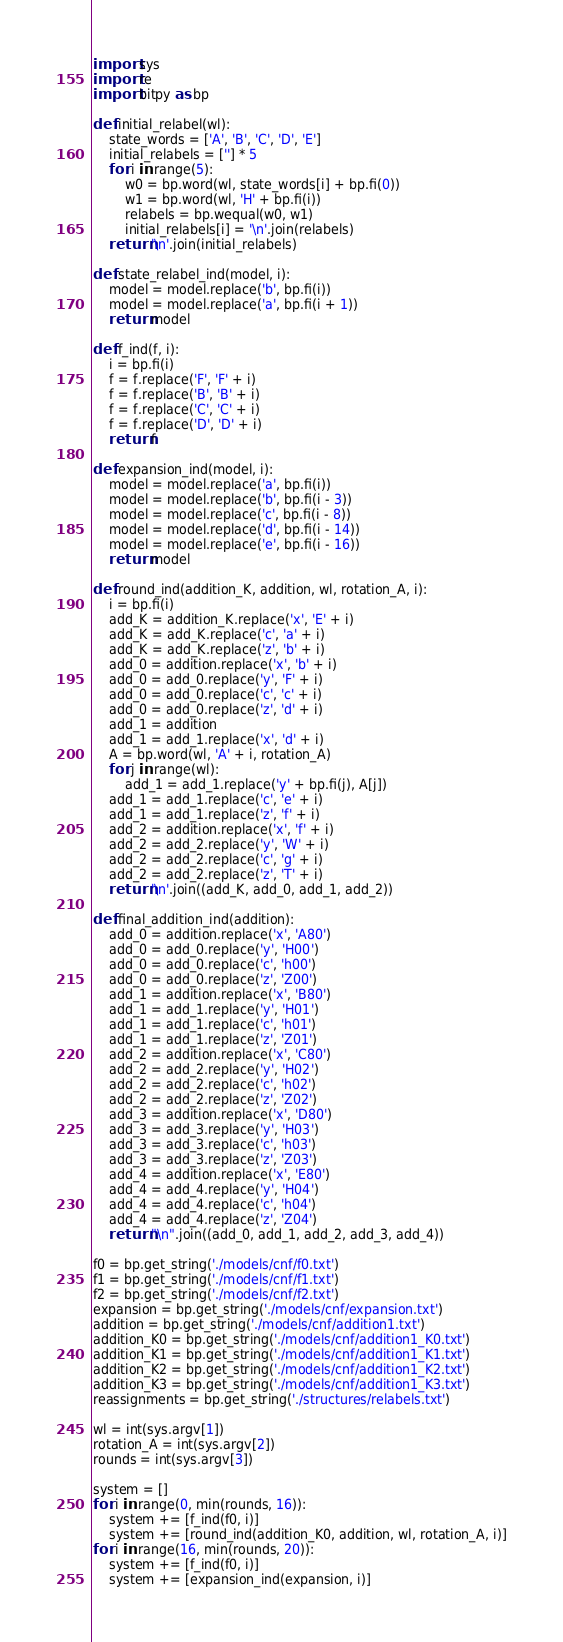<code> <loc_0><loc_0><loc_500><loc_500><_Python_>import sys
import re
import bitpy as bp

def initial_relabel(wl):
    state_words = ['A', 'B', 'C', 'D', 'E']
    initial_relabels = [''] * 5
    for i in range(5):
        w0 = bp.word(wl, state_words[i] + bp.fi(0))
        w1 = bp.word(wl, 'H' + bp.fi(i))
        relabels = bp.wequal(w0, w1)
        initial_relabels[i] = '\n'.join(relabels)
    return '\n'.join(initial_relabels)

def state_relabel_ind(model, i):
    model = model.replace('b', bp.fi(i))
    model = model.replace('a', bp.fi(i + 1))
    return model

def f_ind(f, i):
    i = bp.fi(i)
    f = f.replace('F', 'F' + i)
    f = f.replace('B', 'B' + i)
    f = f.replace('C', 'C' + i)
    f = f.replace('D', 'D' + i)
    return f

def expansion_ind(model, i):
    model = model.replace('a', bp.fi(i))
    model = model.replace('b', bp.fi(i - 3))
    model = model.replace('c', bp.fi(i - 8))
    model = model.replace('d', bp.fi(i - 14))
    model = model.replace('e', bp.fi(i - 16))
    return model

def round_ind(addition_K, addition, wl, rotation_A, i):
    i = bp.fi(i)
    add_K = addition_K.replace('x', 'E' + i)
    add_K = add_K.replace('c', 'a' + i)
    add_K = add_K.replace('z', 'b' + i)
    add_0 = addition.replace('x', 'b' + i)
    add_0 = add_0.replace('y', 'F' + i)
    add_0 = add_0.replace('c', 'c' + i)
    add_0 = add_0.replace('z', 'd' + i)
    add_1 = addition
    add_1 = add_1.replace('x', 'd' + i)
    A = bp.word(wl, 'A' + i, rotation_A)
    for j in range(wl):
        add_1 = add_1.replace('y' + bp.fi(j), A[j])
    add_1 = add_1.replace('c', 'e' + i)
    add_1 = add_1.replace('z', 'f' + i)
    add_2 = addition.replace('x', 'f' + i)
    add_2 = add_2.replace('y', 'W' + i)
    add_2 = add_2.replace('c', 'g' + i)
    add_2 = add_2.replace('z', 'T' + i)
    return '\n'.join((add_K, add_0, add_1, add_2))

def final_addition_ind(addition):
    add_0 = addition.replace('x', 'A80')
    add_0 = add_0.replace('y', 'H00')
    add_0 = add_0.replace('c', 'h00')
    add_0 = add_0.replace('z', 'Z00')
    add_1 = addition.replace('x', 'B80')
    add_1 = add_1.replace('y', 'H01')
    add_1 = add_1.replace('c', 'h01')
    add_1 = add_1.replace('z', 'Z01')
    add_2 = addition.replace('x', 'C80')
    add_2 = add_2.replace('y', 'H02')
    add_2 = add_2.replace('c', 'h02')
    add_2 = add_2.replace('z', 'Z02')
    add_3 = addition.replace('x', 'D80')
    add_3 = add_3.replace('y', 'H03')
    add_3 = add_3.replace('c', 'h03')
    add_3 = add_3.replace('z', 'Z03')
    add_4 = addition.replace('x', 'E80')
    add_4 = add_4.replace('y', 'H04')
    add_4 = add_4.replace('c', 'h04')
    add_4 = add_4.replace('z', 'Z04')
    return "\n".join((add_0, add_1, add_2, add_3, add_4))

f0 = bp.get_string('./models/cnf/f0.txt')
f1 = bp.get_string('./models/cnf/f1.txt')
f2 = bp.get_string('./models/cnf/f2.txt')
expansion = bp.get_string('./models/cnf/expansion.txt')
addition = bp.get_string('./models/cnf/addition1.txt')
addition_K0 = bp.get_string('./models/cnf/addition1_K0.txt')
addition_K1 = bp.get_string('./models/cnf/addition1_K1.txt')
addition_K2 = bp.get_string('./models/cnf/addition1_K2.txt')
addition_K3 = bp.get_string('./models/cnf/addition1_K3.txt')
reassignments = bp.get_string('./structures/relabels.txt')

wl = int(sys.argv[1])
rotation_A = int(sys.argv[2])
rounds = int(sys.argv[3])

system = []
for i in range(0, min(rounds, 16)):
    system += [f_ind(f0, i)]
    system += [round_ind(addition_K0, addition, wl, rotation_A, i)]
for i in range(16, min(rounds, 20)):
    system += [f_ind(f0, i)]
    system += [expansion_ind(expansion, i)]</code> 